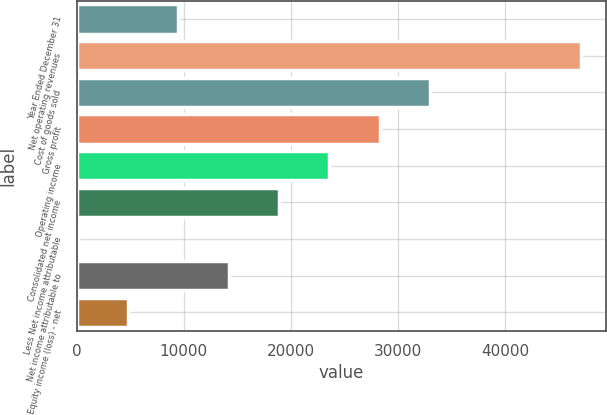Convert chart to OTSL. <chart><loc_0><loc_0><loc_500><loc_500><bar_chart><fcel>Year Ended December 31<fcel>Net operating revenues<fcel>Cost of goods sold<fcel>Gross profit<fcel>Operating income<fcel>Consolidated net income<fcel>Less Net income attributable<fcel>Net income attributable to<fcel>Equity income (loss) - net<nl><fcel>9488.6<fcel>47087<fcel>32987.6<fcel>28287.8<fcel>23588<fcel>18888.2<fcel>89<fcel>14188.4<fcel>4788.8<nl></chart> 